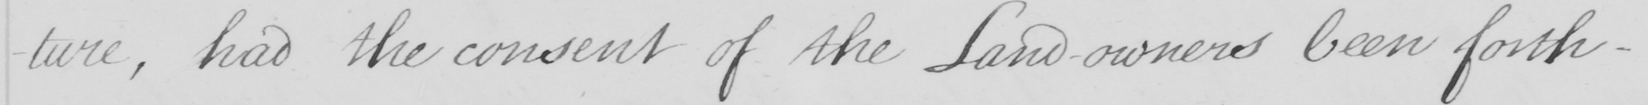What is written in this line of handwriting? -ture , had the consent of the Land-owners been forth- 